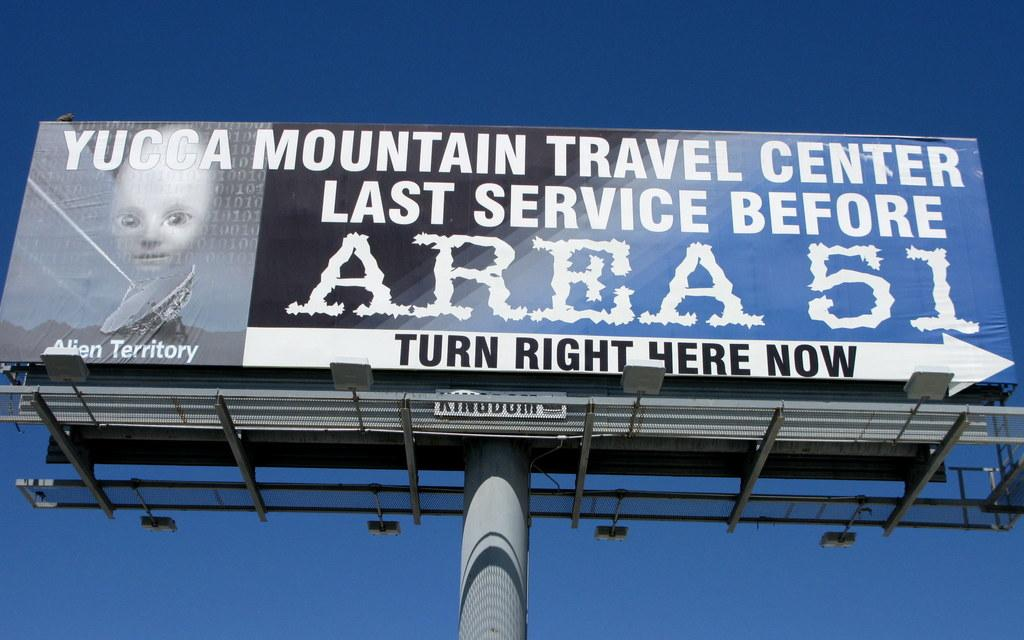<image>
Render a clear and concise summary of the photo. A billboard with the message "Yucca Mountain Travel Center Last Service Before Area 51". 